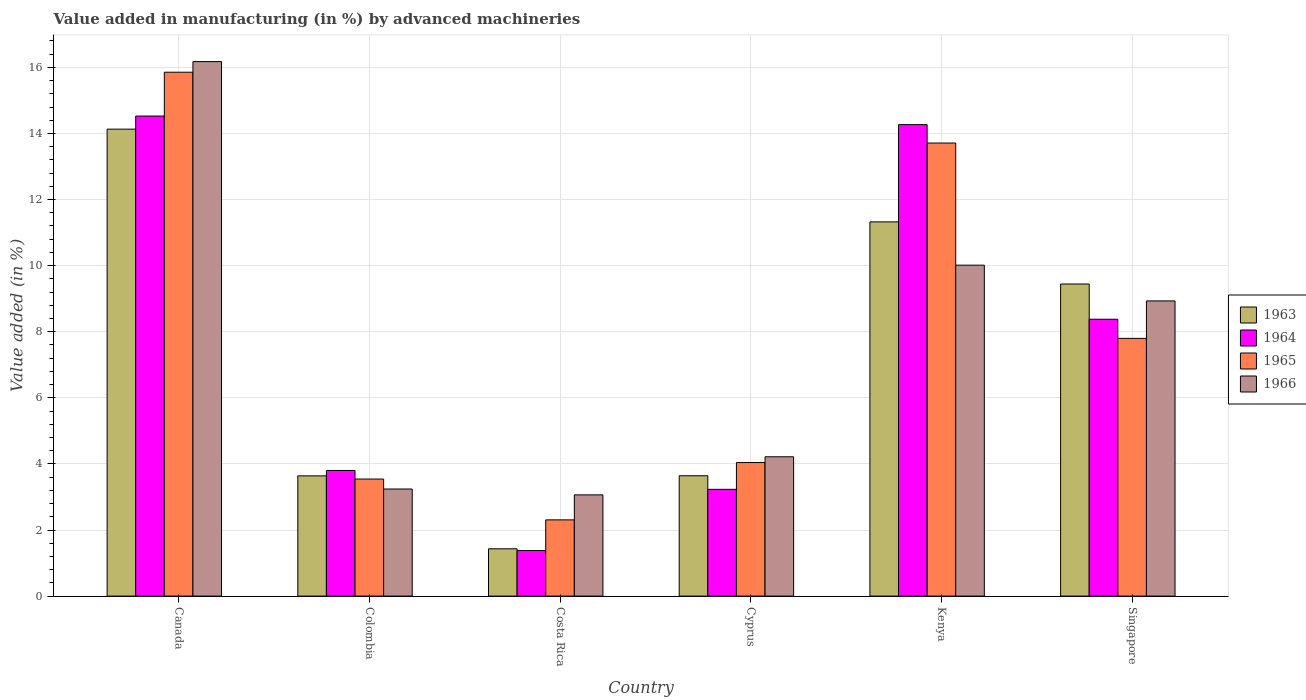How many groups of bars are there?
Your response must be concise. 6. Are the number of bars per tick equal to the number of legend labels?
Your answer should be compact. Yes. Are the number of bars on each tick of the X-axis equal?
Provide a short and direct response. Yes. What is the label of the 1st group of bars from the left?
Your answer should be very brief. Canada. What is the percentage of value added in manufacturing by advanced machineries in 1966 in Colombia?
Ensure brevity in your answer.  3.24. Across all countries, what is the maximum percentage of value added in manufacturing by advanced machineries in 1964?
Your response must be concise. 14.53. Across all countries, what is the minimum percentage of value added in manufacturing by advanced machineries in 1963?
Your answer should be compact. 1.43. In which country was the percentage of value added in manufacturing by advanced machineries in 1964 minimum?
Give a very brief answer. Costa Rica. What is the total percentage of value added in manufacturing by advanced machineries in 1966 in the graph?
Provide a succinct answer. 45.64. What is the difference between the percentage of value added in manufacturing by advanced machineries in 1964 in Canada and that in Cyprus?
Provide a succinct answer. 11.3. What is the difference between the percentage of value added in manufacturing by advanced machineries in 1963 in Canada and the percentage of value added in manufacturing by advanced machineries in 1966 in Kenya?
Keep it short and to the point. 4.12. What is the average percentage of value added in manufacturing by advanced machineries in 1966 per country?
Provide a succinct answer. 7.61. What is the difference between the percentage of value added in manufacturing by advanced machineries of/in 1965 and percentage of value added in manufacturing by advanced machineries of/in 1964 in Colombia?
Give a very brief answer. -0.26. What is the ratio of the percentage of value added in manufacturing by advanced machineries in 1966 in Colombia to that in Costa Rica?
Make the answer very short. 1.06. Is the percentage of value added in manufacturing by advanced machineries in 1965 in Cyprus less than that in Singapore?
Provide a succinct answer. Yes. Is the difference between the percentage of value added in manufacturing by advanced machineries in 1965 in Costa Rica and Kenya greater than the difference between the percentage of value added in manufacturing by advanced machineries in 1964 in Costa Rica and Kenya?
Offer a very short reply. Yes. What is the difference between the highest and the second highest percentage of value added in manufacturing by advanced machineries in 1965?
Offer a very short reply. -5.91. What is the difference between the highest and the lowest percentage of value added in manufacturing by advanced machineries in 1965?
Your response must be concise. 13.55. In how many countries, is the percentage of value added in manufacturing by advanced machineries in 1965 greater than the average percentage of value added in manufacturing by advanced machineries in 1965 taken over all countries?
Your response must be concise. 2. Is the sum of the percentage of value added in manufacturing by advanced machineries in 1965 in Canada and Cyprus greater than the maximum percentage of value added in manufacturing by advanced machineries in 1963 across all countries?
Make the answer very short. Yes. Is it the case that in every country, the sum of the percentage of value added in manufacturing by advanced machineries in 1963 and percentage of value added in manufacturing by advanced machineries in 1964 is greater than the sum of percentage of value added in manufacturing by advanced machineries in 1965 and percentage of value added in manufacturing by advanced machineries in 1966?
Provide a short and direct response. No. What does the 1st bar from the left in Costa Rica represents?
Ensure brevity in your answer.  1963. What does the 2nd bar from the right in Kenya represents?
Your answer should be compact. 1965. Is it the case that in every country, the sum of the percentage of value added in manufacturing by advanced machineries in 1965 and percentage of value added in manufacturing by advanced machineries in 1966 is greater than the percentage of value added in manufacturing by advanced machineries in 1963?
Your answer should be compact. Yes. How many bars are there?
Your answer should be compact. 24. Are all the bars in the graph horizontal?
Offer a very short reply. No. Are the values on the major ticks of Y-axis written in scientific E-notation?
Make the answer very short. No. Does the graph contain any zero values?
Your answer should be very brief. No. Does the graph contain grids?
Your answer should be compact. Yes. Where does the legend appear in the graph?
Keep it short and to the point. Center right. How many legend labels are there?
Offer a very short reply. 4. What is the title of the graph?
Your answer should be very brief. Value added in manufacturing (in %) by advanced machineries. Does "1995" appear as one of the legend labels in the graph?
Ensure brevity in your answer.  No. What is the label or title of the Y-axis?
Keep it short and to the point. Value added (in %). What is the Value added (in %) in 1963 in Canada?
Make the answer very short. 14.13. What is the Value added (in %) of 1964 in Canada?
Give a very brief answer. 14.53. What is the Value added (in %) of 1965 in Canada?
Offer a very short reply. 15.85. What is the Value added (in %) in 1966 in Canada?
Ensure brevity in your answer.  16.17. What is the Value added (in %) of 1963 in Colombia?
Offer a terse response. 3.64. What is the Value added (in %) in 1964 in Colombia?
Provide a short and direct response. 3.8. What is the Value added (in %) of 1965 in Colombia?
Give a very brief answer. 3.54. What is the Value added (in %) of 1966 in Colombia?
Your response must be concise. 3.24. What is the Value added (in %) of 1963 in Costa Rica?
Give a very brief answer. 1.43. What is the Value added (in %) of 1964 in Costa Rica?
Keep it short and to the point. 1.38. What is the Value added (in %) in 1965 in Costa Rica?
Your response must be concise. 2.31. What is the Value added (in %) in 1966 in Costa Rica?
Your answer should be compact. 3.06. What is the Value added (in %) of 1963 in Cyprus?
Your response must be concise. 3.64. What is the Value added (in %) in 1964 in Cyprus?
Keep it short and to the point. 3.23. What is the Value added (in %) of 1965 in Cyprus?
Your answer should be compact. 4.04. What is the Value added (in %) of 1966 in Cyprus?
Ensure brevity in your answer.  4.22. What is the Value added (in %) of 1963 in Kenya?
Your answer should be very brief. 11.32. What is the Value added (in %) in 1964 in Kenya?
Keep it short and to the point. 14.27. What is the Value added (in %) of 1965 in Kenya?
Your answer should be very brief. 13.71. What is the Value added (in %) of 1966 in Kenya?
Provide a succinct answer. 10.01. What is the Value added (in %) of 1963 in Singapore?
Ensure brevity in your answer.  9.44. What is the Value added (in %) of 1964 in Singapore?
Your response must be concise. 8.38. What is the Value added (in %) of 1965 in Singapore?
Make the answer very short. 7.8. What is the Value added (in %) of 1966 in Singapore?
Provide a short and direct response. 8.93. Across all countries, what is the maximum Value added (in %) in 1963?
Provide a succinct answer. 14.13. Across all countries, what is the maximum Value added (in %) of 1964?
Give a very brief answer. 14.53. Across all countries, what is the maximum Value added (in %) of 1965?
Ensure brevity in your answer.  15.85. Across all countries, what is the maximum Value added (in %) in 1966?
Make the answer very short. 16.17. Across all countries, what is the minimum Value added (in %) in 1963?
Provide a succinct answer. 1.43. Across all countries, what is the minimum Value added (in %) in 1964?
Your response must be concise. 1.38. Across all countries, what is the minimum Value added (in %) of 1965?
Provide a short and direct response. 2.31. Across all countries, what is the minimum Value added (in %) of 1966?
Provide a succinct answer. 3.06. What is the total Value added (in %) of 1963 in the graph?
Give a very brief answer. 43.61. What is the total Value added (in %) of 1964 in the graph?
Provide a succinct answer. 45.58. What is the total Value added (in %) of 1965 in the graph?
Provide a succinct answer. 47.25. What is the total Value added (in %) in 1966 in the graph?
Give a very brief answer. 45.64. What is the difference between the Value added (in %) of 1963 in Canada and that in Colombia?
Your answer should be very brief. 10.49. What is the difference between the Value added (in %) of 1964 in Canada and that in Colombia?
Offer a terse response. 10.72. What is the difference between the Value added (in %) of 1965 in Canada and that in Colombia?
Provide a short and direct response. 12.31. What is the difference between the Value added (in %) in 1966 in Canada and that in Colombia?
Your answer should be very brief. 12.93. What is the difference between the Value added (in %) of 1963 in Canada and that in Costa Rica?
Make the answer very short. 12.7. What is the difference between the Value added (in %) of 1964 in Canada and that in Costa Rica?
Ensure brevity in your answer.  13.15. What is the difference between the Value added (in %) of 1965 in Canada and that in Costa Rica?
Ensure brevity in your answer.  13.55. What is the difference between the Value added (in %) of 1966 in Canada and that in Costa Rica?
Your answer should be compact. 13.11. What is the difference between the Value added (in %) in 1963 in Canada and that in Cyprus?
Your answer should be very brief. 10.49. What is the difference between the Value added (in %) in 1964 in Canada and that in Cyprus?
Make the answer very short. 11.3. What is the difference between the Value added (in %) of 1965 in Canada and that in Cyprus?
Offer a very short reply. 11.81. What is the difference between the Value added (in %) in 1966 in Canada and that in Cyprus?
Your answer should be very brief. 11.96. What is the difference between the Value added (in %) in 1963 in Canada and that in Kenya?
Your answer should be compact. 2.81. What is the difference between the Value added (in %) in 1964 in Canada and that in Kenya?
Your answer should be compact. 0.26. What is the difference between the Value added (in %) of 1965 in Canada and that in Kenya?
Make the answer very short. 2.14. What is the difference between the Value added (in %) in 1966 in Canada and that in Kenya?
Offer a terse response. 6.16. What is the difference between the Value added (in %) of 1963 in Canada and that in Singapore?
Your response must be concise. 4.69. What is the difference between the Value added (in %) of 1964 in Canada and that in Singapore?
Make the answer very short. 6.15. What is the difference between the Value added (in %) in 1965 in Canada and that in Singapore?
Provide a short and direct response. 8.05. What is the difference between the Value added (in %) in 1966 in Canada and that in Singapore?
Offer a terse response. 7.24. What is the difference between the Value added (in %) in 1963 in Colombia and that in Costa Rica?
Make the answer very short. 2.21. What is the difference between the Value added (in %) of 1964 in Colombia and that in Costa Rica?
Give a very brief answer. 2.42. What is the difference between the Value added (in %) of 1965 in Colombia and that in Costa Rica?
Your answer should be compact. 1.24. What is the difference between the Value added (in %) in 1966 in Colombia and that in Costa Rica?
Give a very brief answer. 0.18. What is the difference between the Value added (in %) of 1963 in Colombia and that in Cyprus?
Provide a succinct answer. -0. What is the difference between the Value added (in %) in 1964 in Colombia and that in Cyprus?
Your answer should be very brief. 0.57. What is the difference between the Value added (in %) in 1965 in Colombia and that in Cyprus?
Your answer should be compact. -0.5. What is the difference between the Value added (in %) of 1966 in Colombia and that in Cyprus?
Give a very brief answer. -0.97. What is the difference between the Value added (in %) in 1963 in Colombia and that in Kenya?
Provide a short and direct response. -7.69. What is the difference between the Value added (in %) in 1964 in Colombia and that in Kenya?
Ensure brevity in your answer.  -10.47. What is the difference between the Value added (in %) in 1965 in Colombia and that in Kenya?
Provide a succinct answer. -10.17. What is the difference between the Value added (in %) in 1966 in Colombia and that in Kenya?
Keep it short and to the point. -6.77. What is the difference between the Value added (in %) of 1963 in Colombia and that in Singapore?
Provide a short and direct response. -5.81. What is the difference between the Value added (in %) of 1964 in Colombia and that in Singapore?
Offer a terse response. -4.58. What is the difference between the Value added (in %) of 1965 in Colombia and that in Singapore?
Ensure brevity in your answer.  -4.26. What is the difference between the Value added (in %) of 1966 in Colombia and that in Singapore?
Keep it short and to the point. -5.69. What is the difference between the Value added (in %) in 1963 in Costa Rica and that in Cyprus?
Your response must be concise. -2.21. What is the difference between the Value added (in %) in 1964 in Costa Rica and that in Cyprus?
Ensure brevity in your answer.  -1.85. What is the difference between the Value added (in %) of 1965 in Costa Rica and that in Cyprus?
Your answer should be very brief. -1.73. What is the difference between the Value added (in %) of 1966 in Costa Rica and that in Cyprus?
Your response must be concise. -1.15. What is the difference between the Value added (in %) in 1963 in Costa Rica and that in Kenya?
Your answer should be compact. -9.89. What is the difference between the Value added (in %) in 1964 in Costa Rica and that in Kenya?
Your response must be concise. -12.89. What is the difference between the Value added (in %) in 1965 in Costa Rica and that in Kenya?
Offer a terse response. -11.4. What is the difference between the Value added (in %) in 1966 in Costa Rica and that in Kenya?
Make the answer very short. -6.95. What is the difference between the Value added (in %) of 1963 in Costa Rica and that in Singapore?
Your response must be concise. -8.01. What is the difference between the Value added (in %) in 1964 in Costa Rica and that in Singapore?
Keep it short and to the point. -7. What is the difference between the Value added (in %) of 1965 in Costa Rica and that in Singapore?
Give a very brief answer. -5.49. What is the difference between the Value added (in %) in 1966 in Costa Rica and that in Singapore?
Ensure brevity in your answer.  -5.87. What is the difference between the Value added (in %) in 1963 in Cyprus and that in Kenya?
Your answer should be compact. -7.68. What is the difference between the Value added (in %) in 1964 in Cyprus and that in Kenya?
Make the answer very short. -11.04. What is the difference between the Value added (in %) of 1965 in Cyprus and that in Kenya?
Your answer should be compact. -9.67. What is the difference between the Value added (in %) of 1966 in Cyprus and that in Kenya?
Offer a very short reply. -5.8. What is the difference between the Value added (in %) in 1963 in Cyprus and that in Singapore?
Your response must be concise. -5.8. What is the difference between the Value added (in %) in 1964 in Cyprus and that in Singapore?
Offer a terse response. -5.15. What is the difference between the Value added (in %) in 1965 in Cyprus and that in Singapore?
Your answer should be compact. -3.76. What is the difference between the Value added (in %) of 1966 in Cyprus and that in Singapore?
Provide a short and direct response. -4.72. What is the difference between the Value added (in %) of 1963 in Kenya and that in Singapore?
Provide a short and direct response. 1.88. What is the difference between the Value added (in %) in 1964 in Kenya and that in Singapore?
Your answer should be very brief. 5.89. What is the difference between the Value added (in %) of 1965 in Kenya and that in Singapore?
Provide a succinct answer. 5.91. What is the difference between the Value added (in %) in 1966 in Kenya and that in Singapore?
Ensure brevity in your answer.  1.08. What is the difference between the Value added (in %) in 1963 in Canada and the Value added (in %) in 1964 in Colombia?
Offer a very short reply. 10.33. What is the difference between the Value added (in %) of 1963 in Canada and the Value added (in %) of 1965 in Colombia?
Your response must be concise. 10.59. What is the difference between the Value added (in %) in 1963 in Canada and the Value added (in %) in 1966 in Colombia?
Make the answer very short. 10.89. What is the difference between the Value added (in %) of 1964 in Canada and the Value added (in %) of 1965 in Colombia?
Offer a terse response. 10.98. What is the difference between the Value added (in %) of 1964 in Canada and the Value added (in %) of 1966 in Colombia?
Ensure brevity in your answer.  11.29. What is the difference between the Value added (in %) in 1965 in Canada and the Value added (in %) in 1966 in Colombia?
Offer a terse response. 12.61. What is the difference between the Value added (in %) in 1963 in Canada and the Value added (in %) in 1964 in Costa Rica?
Your answer should be compact. 12.75. What is the difference between the Value added (in %) of 1963 in Canada and the Value added (in %) of 1965 in Costa Rica?
Offer a terse response. 11.82. What is the difference between the Value added (in %) in 1963 in Canada and the Value added (in %) in 1966 in Costa Rica?
Make the answer very short. 11.07. What is the difference between the Value added (in %) in 1964 in Canada and the Value added (in %) in 1965 in Costa Rica?
Provide a short and direct response. 12.22. What is the difference between the Value added (in %) of 1964 in Canada and the Value added (in %) of 1966 in Costa Rica?
Your answer should be compact. 11.46. What is the difference between the Value added (in %) of 1965 in Canada and the Value added (in %) of 1966 in Costa Rica?
Make the answer very short. 12.79. What is the difference between the Value added (in %) in 1963 in Canada and the Value added (in %) in 1964 in Cyprus?
Ensure brevity in your answer.  10.9. What is the difference between the Value added (in %) of 1963 in Canada and the Value added (in %) of 1965 in Cyprus?
Offer a terse response. 10.09. What is the difference between the Value added (in %) of 1963 in Canada and the Value added (in %) of 1966 in Cyprus?
Make the answer very short. 9.92. What is the difference between the Value added (in %) of 1964 in Canada and the Value added (in %) of 1965 in Cyprus?
Provide a succinct answer. 10.49. What is the difference between the Value added (in %) in 1964 in Canada and the Value added (in %) in 1966 in Cyprus?
Ensure brevity in your answer.  10.31. What is the difference between the Value added (in %) of 1965 in Canada and the Value added (in %) of 1966 in Cyprus?
Ensure brevity in your answer.  11.64. What is the difference between the Value added (in %) in 1963 in Canada and the Value added (in %) in 1964 in Kenya?
Your answer should be compact. -0.14. What is the difference between the Value added (in %) of 1963 in Canada and the Value added (in %) of 1965 in Kenya?
Offer a terse response. 0.42. What is the difference between the Value added (in %) of 1963 in Canada and the Value added (in %) of 1966 in Kenya?
Keep it short and to the point. 4.12. What is the difference between the Value added (in %) of 1964 in Canada and the Value added (in %) of 1965 in Kenya?
Provide a short and direct response. 0.82. What is the difference between the Value added (in %) in 1964 in Canada and the Value added (in %) in 1966 in Kenya?
Provide a succinct answer. 4.51. What is the difference between the Value added (in %) in 1965 in Canada and the Value added (in %) in 1966 in Kenya?
Your response must be concise. 5.84. What is the difference between the Value added (in %) in 1963 in Canada and the Value added (in %) in 1964 in Singapore?
Your response must be concise. 5.75. What is the difference between the Value added (in %) in 1963 in Canada and the Value added (in %) in 1965 in Singapore?
Offer a terse response. 6.33. What is the difference between the Value added (in %) of 1963 in Canada and the Value added (in %) of 1966 in Singapore?
Your answer should be very brief. 5.2. What is the difference between the Value added (in %) of 1964 in Canada and the Value added (in %) of 1965 in Singapore?
Ensure brevity in your answer.  6.73. What is the difference between the Value added (in %) in 1964 in Canada and the Value added (in %) in 1966 in Singapore?
Make the answer very short. 5.59. What is the difference between the Value added (in %) in 1965 in Canada and the Value added (in %) in 1966 in Singapore?
Provide a succinct answer. 6.92. What is the difference between the Value added (in %) of 1963 in Colombia and the Value added (in %) of 1964 in Costa Rica?
Your answer should be compact. 2.26. What is the difference between the Value added (in %) of 1963 in Colombia and the Value added (in %) of 1965 in Costa Rica?
Provide a succinct answer. 1.33. What is the difference between the Value added (in %) in 1963 in Colombia and the Value added (in %) in 1966 in Costa Rica?
Give a very brief answer. 0.57. What is the difference between the Value added (in %) of 1964 in Colombia and the Value added (in %) of 1965 in Costa Rica?
Ensure brevity in your answer.  1.49. What is the difference between the Value added (in %) of 1964 in Colombia and the Value added (in %) of 1966 in Costa Rica?
Keep it short and to the point. 0.74. What is the difference between the Value added (in %) in 1965 in Colombia and the Value added (in %) in 1966 in Costa Rica?
Your response must be concise. 0.48. What is the difference between the Value added (in %) of 1963 in Colombia and the Value added (in %) of 1964 in Cyprus?
Offer a terse response. 0.41. What is the difference between the Value added (in %) of 1963 in Colombia and the Value added (in %) of 1965 in Cyprus?
Ensure brevity in your answer.  -0.4. What is the difference between the Value added (in %) in 1963 in Colombia and the Value added (in %) in 1966 in Cyprus?
Give a very brief answer. -0.58. What is the difference between the Value added (in %) of 1964 in Colombia and the Value added (in %) of 1965 in Cyprus?
Make the answer very short. -0.24. What is the difference between the Value added (in %) in 1964 in Colombia and the Value added (in %) in 1966 in Cyprus?
Ensure brevity in your answer.  -0.41. What is the difference between the Value added (in %) in 1965 in Colombia and the Value added (in %) in 1966 in Cyprus?
Keep it short and to the point. -0.67. What is the difference between the Value added (in %) of 1963 in Colombia and the Value added (in %) of 1964 in Kenya?
Ensure brevity in your answer.  -10.63. What is the difference between the Value added (in %) of 1963 in Colombia and the Value added (in %) of 1965 in Kenya?
Provide a succinct answer. -10.07. What is the difference between the Value added (in %) of 1963 in Colombia and the Value added (in %) of 1966 in Kenya?
Keep it short and to the point. -6.38. What is the difference between the Value added (in %) of 1964 in Colombia and the Value added (in %) of 1965 in Kenya?
Provide a short and direct response. -9.91. What is the difference between the Value added (in %) of 1964 in Colombia and the Value added (in %) of 1966 in Kenya?
Keep it short and to the point. -6.21. What is the difference between the Value added (in %) of 1965 in Colombia and the Value added (in %) of 1966 in Kenya?
Give a very brief answer. -6.47. What is the difference between the Value added (in %) of 1963 in Colombia and the Value added (in %) of 1964 in Singapore?
Provide a short and direct response. -4.74. What is the difference between the Value added (in %) of 1963 in Colombia and the Value added (in %) of 1965 in Singapore?
Make the answer very short. -4.16. What is the difference between the Value added (in %) in 1963 in Colombia and the Value added (in %) in 1966 in Singapore?
Make the answer very short. -5.29. What is the difference between the Value added (in %) of 1964 in Colombia and the Value added (in %) of 1965 in Singapore?
Ensure brevity in your answer.  -4. What is the difference between the Value added (in %) of 1964 in Colombia and the Value added (in %) of 1966 in Singapore?
Your answer should be very brief. -5.13. What is the difference between the Value added (in %) of 1965 in Colombia and the Value added (in %) of 1966 in Singapore?
Ensure brevity in your answer.  -5.39. What is the difference between the Value added (in %) in 1963 in Costa Rica and the Value added (in %) in 1964 in Cyprus?
Make the answer very short. -1.8. What is the difference between the Value added (in %) of 1963 in Costa Rica and the Value added (in %) of 1965 in Cyprus?
Your answer should be very brief. -2.61. What is the difference between the Value added (in %) of 1963 in Costa Rica and the Value added (in %) of 1966 in Cyprus?
Your response must be concise. -2.78. What is the difference between the Value added (in %) of 1964 in Costa Rica and the Value added (in %) of 1965 in Cyprus?
Offer a terse response. -2.66. What is the difference between the Value added (in %) in 1964 in Costa Rica and the Value added (in %) in 1966 in Cyprus?
Your response must be concise. -2.84. What is the difference between the Value added (in %) of 1965 in Costa Rica and the Value added (in %) of 1966 in Cyprus?
Your response must be concise. -1.91. What is the difference between the Value added (in %) of 1963 in Costa Rica and the Value added (in %) of 1964 in Kenya?
Give a very brief answer. -12.84. What is the difference between the Value added (in %) of 1963 in Costa Rica and the Value added (in %) of 1965 in Kenya?
Give a very brief answer. -12.28. What is the difference between the Value added (in %) in 1963 in Costa Rica and the Value added (in %) in 1966 in Kenya?
Ensure brevity in your answer.  -8.58. What is the difference between the Value added (in %) of 1964 in Costa Rica and the Value added (in %) of 1965 in Kenya?
Keep it short and to the point. -12.33. What is the difference between the Value added (in %) in 1964 in Costa Rica and the Value added (in %) in 1966 in Kenya?
Provide a short and direct response. -8.64. What is the difference between the Value added (in %) in 1965 in Costa Rica and the Value added (in %) in 1966 in Kenya?
Keep it short and to the point. -7.71. What is the difference between the Value added (in %) of 1963 in Costa Rica and the Value added (in %) of 1964 in Singapore?
Your response must be concise. -6.95. What is the difference between the Value added (in %) in 1963 in Costa Rica and the Value added (in %) in 1965 in Singapore?
Offer a very short reply. -6.37. What is the difference between the Value added (in %) in 1963 in Costa Rica and the Value added (in %) in 1966 in Singapore?
Your response must be concise. -7.5. What is the difference between the Value added (in %) in 1964 in Costa Rica and the Value added (in %) in 1965 in Singapore?
Give a very brief answer. -6.42. What is the difference between the Value added (in %) of 1964 in Costa Rica and the Value added (in %) of 1966 in Singapore?
Your answer should be compact. -7.55. What is the difference between the Value added (in %) of 1965 in Costa Rica and the Value added (in %) of 1966 in Singapore?
Offer a terse response. -6.63. What is the difference between the Value added (in %) in 1963 in Cyprus and the Value added (in %) in 1964 in Kenya?
Your response must be concise. -10.63. What is the difference between the Value added (in %) in 1963 in Cyprus and the Value added (in %) in 1965 in Kenya?
Your response must be concise. -10.07. What is the difference between the Value added (in %) in 1963 in Cyprus and the Value added (in %) in 1966 in Kenya?
Offer a very short reply. -6.37. What is the difference between the Value added (in %) in 1964 in Cyprus and the Value added (in %) in 1965 in Kenya?
Your answer should be very brief. -10.48. What is the difference between the Value added (in %) of 1964 in Cyprus and the Value added (in %) of 1966 in Kenya?
Offer a terse response. -6.78. What is the difference between the Value added (in %) of 1965 in Cyprus and the Value added (in %) of 1966 in Kenya?
Your answer should be compact. -5.97. What is the difference between the Value added (in %) in 1963 in Cyprus and the Value added (in %) in 1964 in Singapore?
Offer a terse response. -4.74. What is the difference between the Value added (in %) in 1963 in Cyprus and the Value added (in %) in 1965 in Singapore?
Give a very brief answer. -4.16. What is the difference between the Value added (in %) of 1963 in Cyprus and the Value added (in %) of 1966 in Singapore?
Provide a succinct answer. -5.29. What is the difference between the Value added (in %) of 1964 in Cyprus and the Value added (in %) of 1965 in Singapore?
Your answer should be compact. -4.57. What is the difference between the Value added (in %) in 1964 in Cyprus and the Value added (in %) in 1966 in Singapore?
Your response must be concise. -5.7. What is the difference between the Value added (in %) in 1965 in Cyprus and the Value added (in %) in 1966 in Singapore?
Provide a short and direct response. -4.89. What is the difference between the Value added (in %) in 1963 in Kenya and the Value added (in %) in 1964 in Singapore?
Your answer should be compact. 2.95. What is the difference between the Value added (in %) of 1963 in Kenya and the Value added (in %) of 1965 in Singapore?
Provide a short and direct response. 3.52. What is the difference between the Value added (in %) of 1963 in Kenya and the Value added (in %) of 1966 in Singapore?
Offer a terse response. 2.39. What is the difference between the Value added (in %) in 1964 in Kenya and the Value added (in %) in 1965 in Singapore?
Your answer should be compact. 6.47. What is the difference between the Value added (in %) in 1964 in Kenya and the Value added (in %) in 1966 in Singapore?
Give a very brief answer. 5.33. What is the difference between the Value added (in %) in 1965 in Kenya and the Value added (in %) in 1966 in Singapore?
Your response must be concise. 4.78. What is the average Value added (in %) of 1963 per country?
Your answer should be very brief. 7.27. What is the average Value added (in %) in 1964 per country?
Your answer should be compact. 7.6. What is the average Value added (in %) of 1965 per country?
Offer a very short reply. 7.88. What is the average Value added (in %) in 1966 per country?
Provide a succinct answer. 7.61. What is the difference between the Value added (in %) in 1963 and Value added (in %) in 1964 in Canada?
Offer a terse response. -0.4. What is the difference between the Value added (in %) in 1963 and Value added (in %) in 1965 in Canada?
Provide a short and direct response. -1.72. What is the difference between the Value added (in %) in 1963 and Value added (in %) in 1966 in Canada?
Your response must be concise. -2.04. What is the difference between the Value added (in %) in 1964 and Value added (in %) in 1965 in Canada?
Your response must be concise. -1.33. What is the difference between the Value added (in %) in 1964 and Value added (in %) in 1966 in Canada?
Ensure brevity in your answer.  -1.65. What is the difference between the Value added (in %) in 1965 and Value added (in %) in 1966 in Canada?
Provide a succinct answer. -0.32. What is the difference between the Value added (in %) of 1963 and Value added (in %) of 1964 in Colombia?
Offer a very short reply. -0.16. What is the difference between the Value added (in %) of 1963 and Value added (in %) of 1965 in Colombia?
Keep it short and to the point. 0.1. What is the difference between the Value added (in %) in 1963 and Value added (in %) in 1966 in Colombia?
Ensure brevity in your answer.  0.4. What is the difference between the Value added (in %) in 1964 and Value added (in %) in 1965 in Colombia?
Keep it short and to the point. 0.26. What is the difference between the Value added (in %) in 1964 and Value added (in %) in 1966 in Colombia?
Your answer should be compact. 0.56. What is the difference between the Value added (in %) in 1965 and Value added (in %) in 1966 in Colombia?
Your answer should be very brief. 0.3. What is the difference between the Value added (in %) of 1963 and Value added (in %) of 1964 in Costa Rica?
Offer a terse response. 0.05. What is the difference between the Value added (in %) of 1963 and Value added (in %) of 1965 in Costa Rica?
Your answer should be compact. -0.88. What is the difference between the Value added (in %) in 1963 and Value added (in %) in 1966 in Costa Rica?
Offer a very short reply. -1.63. What is the difference between the Value added (in %) in 1964 and Value added (in %) in 1965 in Costa Rica?
Keep it short and to the point. -0.93. What is the difference between the Value added (in %) of 1964 and Value added (in %) of 1966 in Costa Rica?
Your answer should be very brief. -1.69. What is the difference between the Value added (in %) of 1965 and Value added (in %) of 1966 in Costa Rica?
Offer a terse response. -0.76. What is the difference between the Value added (in %) in 1963 and Value added (in %) in 1964 in Cyprus?
Give a very brief answer. 0.41. What is the difference between the Value added (in %) in 1963 and Value added (in %) in 1965 in Cyprus?
Make the answer very short. -0.4. What is the difference between the Value added (in %) in 1963 and Value added (in %) in 1966 in Cyprus?
Keep it short and to the point. -0.57. What is the difference between the Value added (in %) in 1964 and Value added (in %) in 1965 in Cyprus?
Offer a terse response. -0.81. What is the difference between the Value added (in %) in 1964 and Value added (in %) in 1966 in Cyprus?
Your response must be concise. -0.98. What is the difference between the Value added (in %) in 1965 and Value added (in %) in 1966 in Cyprus?
Provide a succinct answer. -0.17. What is the difference between the Value added (in %) of 1963 and Value added (in %) of 1964 in Kenya?
Offer a terse response. -2.94. What is the difference between the Value added (in %) in 1963 and Value added (in %) in 1965 in Kenya?
Your response must be concise. -2.39. What is the difference between the Value added (in %) of 1963 and Value added (in %) of 1966 in Kenya?
Provide a succinct answer. 1.31. What is the difference between the Value added (in %) in 1964 and Value added (in %) in 1965 in Kenya?
Your answer should be very brief. 0.56. What is the difference between the Value added (in %) of 1964 and Value added (in %) of 1966 in Kenya?
Offer a very short reply. 4.25. What is the difference between the Value added (in %) in 1965 and Value added (in %) in 1966 in Kenya?
Provide a succinct answer. 3.7. What is the difference between the Value added (in %) in 1963 and Value added (in %) in 1964 in Singapore?
Your answer should be compact. 1.07. What is the difference between the Value added (in %) in 1963 and Value added (in %) in 1965 in Singapore?
Give a very brief answer. 1.64. What is the difference between the Value added (in %) in 1963 and Value added (in %) in 1966 in Singapore?
Your answer should be compact. 0.51. What is the difference between the Value added (in %) in 1964 and Value added (in %) in 1965 in Singapore?
Provide a short and direct response. 0.58. What is the difference between the Value added (in %) in 1964 and Value added (in %) in 1966 in Singapore?
Your answer should be compact. -0.55. What is the difference between the Value added (in %) of 1965 and Value added (in %) of 1966 in Singapore?
Keep it short and to the point. -1.13. What is the ratio of the Value added (in %) of 1963 in Canada to that in Colombia?
Your answer should be compact. 3.88. What is the ratio of the Value added (in %) of 1964 in Canada to that in Colombia?
Keep it short and to the point. 3.82. What is the ratio of the Value added (in %) of 1965 in Canada to that in Colombia?
Provide a succinct answer. 4.48. What is the ratio of the Value added (in %) in 1966 in Canada to that in Colombia?
Keep it short and to the point. 4.99. What is the ratio of the Value added (in %) of 1963 in Canada to that in Costa Rica?
Offer a very short reply. 9.87. What is the ratio of the Value added (in %) of 1964 in Canada to that in Costa Rica?
Your answer should be compact. 10.54. What is the ratio of the Value added (in %) of 1965 in Canada to that in Costa Rica?
Your response must be concise. 6.87. What is the ratio of the Value added (in %) of 1966 in Canada to that in Costa Rica?
Ensure brevity in your answer.  5.28. What is the ratio of the Value added (in %) of 1963 in Canada to that in Cyprus?
Make the answer very short. 3.88. What is the ratio of the Value added (in %) of 1964 in Canada to that in Cyprus?
Keep it short and to the point. 4.5. What is the ratio of the Value added (in %) in 1965 in Canada to that in Cyprus?
Give a very brief answer. 3.92. What is the ratio of the Value added (in %) of 1966 in Canada to that in Cyprus?
Offer a very short reply. 3.84. What is the ratio of the Value added (in %) of 1963 in Canada to that in Kenya?
Make the answer very short. 1.25. What is the ratio of the Value added (in %) of 1964 in Canada to that in Kenya?
Ensure brevity in your answer.  1.02. What is the ratio of the Value added (in %) of 1965 in Canada to that in Kenya?
Offer a terse response. 1.16. What is the ratio of the Value added (in %) in 1966 in Canada to that in Kenya?
Your response must be concise. 1.62. What is the ratio of the Value added (in %) in 1963 in Canada to that in Singapore?
Give a very brief answer. 1.5. What is the ratio of the Value added (in %) of 1964 in Canada to that in Singapore?
Make the answer very short. 1.73. What is the ratio of the Value added (in %) of 1965 in Canada to that in Singapore?
Make the answer very short. 2.03. What is the ratio of the Value added (in %) in 1966 in Canada to that in Singapore?
Your answer should be compact. 1.81. What is the ratio of the Value added (in %) of 1963 in Colombia to that in Costa Rica?
Offer a terse response. 2.54. What is the ratio of the Value added (in %) of 1964 in Colombia to that in Costa Rica?
Offer a terse response. 2.76. What is the ratio of the Value added (in %) in 1965 in Colombia to that in Costa Rica?
Give a very brief answer. 1.54. What is the ratio of the Value added (in %) of 1966 in Colombia to that in Costa Rica?
Make the answer very short. 1.06. What is the ratio of the Value added (in %) of 1964 in Colombia to that in Cyprus?
Make the answer very short. 1.18. What is the ratio of the Value added (in %) of 1965 in Colombia to that in Cyprus?
Keep it short and to the point. 0.88. What is the ratio of the Value added (in %) of 1966 in Colombia to that in Cyprus?
Give a very brief answer. 0.77. What is the ratio of the Value added (in %) in 1963 in Colombia to that in Kenya?
Offer a very short reply. 0.32. What is the ratio of the Value added (in %) in 1964 in Colombia to that in Kenya?
Your response must be concise. 0.27. What is the ratio of the Value added (in %) of 1965 in Colombia to that in Kenya?
Provide a short and direct response. 0.26. What is the ratio of the Value added (in %) in 1966 in Colombia to that in Kenya?
Keep it short and to the point. 0.32. What is the ratio of the Value added (in %) in 1963 in Colombia to that in Singapore?
Offer a very short reply. 0.39. What is the ratio of the Value added (in %) in 1964 in Colombia to that in Singapore?
Your answer should be compact. 0.45. What is the ratio of the Value added (in %) in 1965 in Colombia to that in Singapore?
Offer a very short reply. 0.45. What is the ratio of the Value added (in %) in 1966 in Colombia to that in Singapore?
Your response must be concise. 0.36. What is the ratio of the Value added (in %) of 1963 in Costa Rica to that in Cyprus?
Your answer should be very brief. 0.39. What is the ratio of the Value added (in %) of 1964 in Costa Rica to that in Cyprus?
Your response must be concise. 0.43. What is the ratio of the Value added (in %) in 1965 in Costa Rica to that in Cyprus?
Keep it short and to the point. 0.57. What is the ratio of the Value added (in %) in 1966 in Costa Rica to that in Cyprus?
Provide a succinct answer. 0.73. What is the ratio of the Value added (in %) in 1963 in Costa Rica to that in Kenya?
Your answer should be compact. 0.13. What is the ratio of the Value added (in %) of 1964 in Costa Rica to that in Kenya?
Your answer should be very brief. 0.1. What is the ratio of the Value added (in %) of 1965 in Costa Rica to that in Kenya?
Your answer should be very brief. 0.17. What is the ratio of the Value added (in %) in 1966 in Costa Rica to that in Kenya?
Offer a very short reply. 0.31. What is the ratio of the Value added (in %) of 1963 in Costa Rica to that in Singapore?
Your answer should be compact. 0.15. What is the ratio of the Value added (in %) of 1964 in Costa Rica to that in Singapore?
Your answer should be very brief. 0.16. What is the ratio of the Value added (in %) of 1965 in Costa Rica to that in Singapore?
Give a very brief answer. 0.3. What is the ratio of the Value added (in %) in 1966 in Costa Rica to that in Singapore?
Offer a terse response. 0.34. What is the ratio of the Value added (in %) of 1963 in Cyprus to that in Kenya?
Your response must be concise. 0.32. What is the ratio of the Value added (in %) in 1964 in Cyprus to that in Kenya?
Your answer should be very brief. 0.23. What is the ratio of the Value added (in %) in 1965 in Cyprus to that in Kenya?
Provide a succinct answer. 0.29. What is the ratio of the Value added (in %) of 1966 in Cyprus to that in Kenya?
Keep it short and to the point. 0.42. What is the ratio of the Value added (in %) of 1963 in Cyprus to that in Singapore?
Provide a short and direct response. 0.39. What is the ratio of the Value added (in %) of 1964 in Cyprus to that in Singapore?
Provide a succinct answer. 0.39. What is the ratio of the Value added (in %) in 1965 in Cyprus to that in Singapore?
Provide a short and direct response. 0.52. What is the ratio of the Value added (in %) of 1966 in Cyprus to that in Singapore?
Provide a succinct answer. 0.47. What is the ratio of the Value added (in %) of 1963 in Kenya to that in Singapore?
Your answer should be very brief. 1.2. What is the ratio of the Value added (in %) of 1964 in Kenya to that in Singapore?
Offer a terse response. 1.7. What is the ratio of the Value added (in %) in 1965 in Kenya to that in Singapore?
Ensure brevity in your answer.  1.76. What is the ratio of the Value added (in %) of 1966 in Kenya to that in Singapore?
Provide a short and direct response. 1.12. What is the difference between the highest and the second highest Value added (in %) of 1963?
Offer a very short reply. 2.81. What is the difference between the highest and the second highest Value added (in %) in 1964?
Offer a terse response. 0.26. What is the difference between the highest and the second highest Value added (in %) in 1965?
Ensure brevity in your answer.  2.14. What is the difference between the highest and the second highest Value added (in %) of 1966?
Your answer should be compact. 6.16. What is the difference between the highest and the lowest Value added (in %) of 1963?
Your response must be concise. 12.7. What is the difference between the highest and the lowest Value added (in %) in 1964?
Your response must be concise. 13.15. What is the difference between the highest and the lowest Value added (in %) of 1965?
Offer a very short reply. 13.55. What is the difference between the highest and the lowest Value added (in %) in 1966?
Make the answer very short. 13.11. 